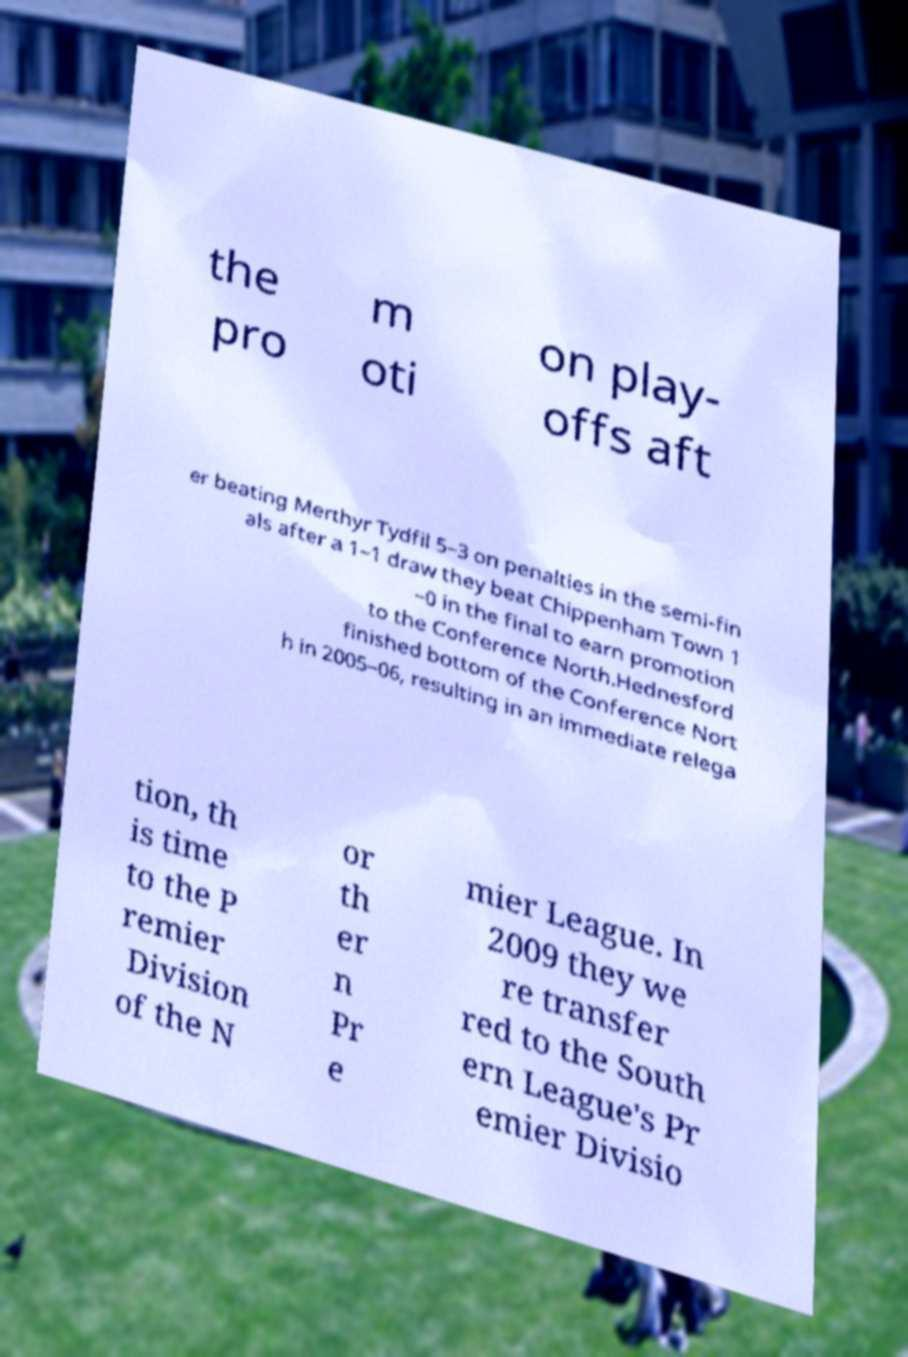There's text embedded in this image that I need extracted. Can you transcribe it verbatim? the pro m oti on play- offs aft er beating Merthyr Tydfil 5–3 on penalties in the semi-fin als after a 1–1 draw they beat Chippenham Town 1 –0 in the final to earn promotion to the Conference North.Hednesford finished bottom of the Conference Nort h in 2005–06, resulting in an immediate relega tion, th is time to the P remier Division of the N or th er n Pr e mier League. In 2009 they we re transfer red to the South ern League's Pr emier Divisio 